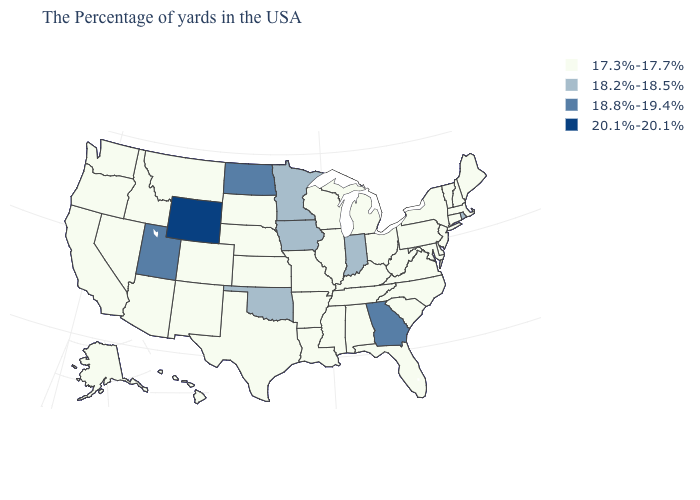Does the map have missing data?
Quick response, please. No. What is the value of Delaware?
Quick response, please. 17.3%-17.7%. What is the value of Louisiana?
Keep it brief. 17.3%-17.7%. Does Minnesota have the same value as Indiana?
Quick response, please. Yes. Does Massachusetts have a lower value than North Carolina?
Concise answer only. No. Name the states that have a value in the range 18.2%-18.5%?
Give a very brief answer. Rhode Island, Indiana, Minnesota, Iowa, Oklahoma. What is the value of Arizona?
Short answer required. 17.3%-17.7%. Name the states that have a value in the range 18.8%-19.4%?
Keep it brief. Georgia, North Dakota, Utah. Does the map have missing data?
Answer briefly. No. Name the states that have a value in the range 20.1%-20.1%?
Give a very brief answer. Wyoming. What is the highest value in states that border Utah?
Answer briefly. 20.1%-20.1%. Does the map have missing data?
Short answer required. No. What is the value of Nevada?
Answer briefly. 17.3%-17.7%. What is the value of Ohio?
Write a very short answer. 17.3%-17.7%. What is the value of Alabama?
Short answer required. 17.3%-17.7%. 